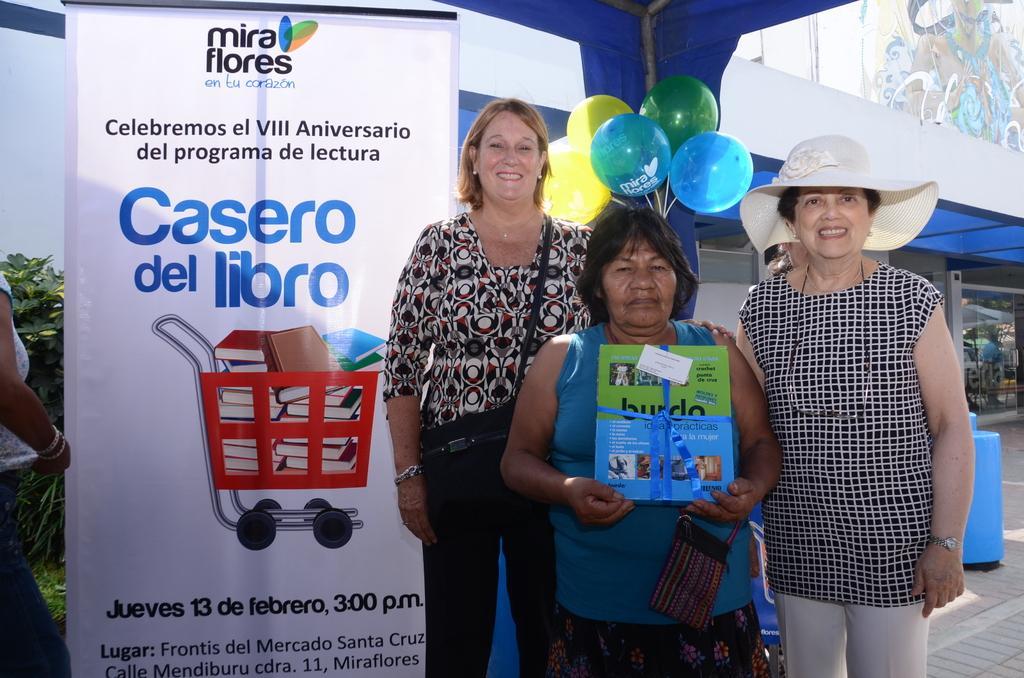Please provide a concise description of this image. In this image I can see four women are standing and I can see one of them is holding few things and a bag. I can also see two women are smiling and I can see one of them is wearing a hat and the second one is carrying a bag. In the background I can see a whiteboard, few balloons, a building and on the board I can see something is written. On the left side of the image I can see a plant and on the top right side of the image I can see a painting on the wall. 